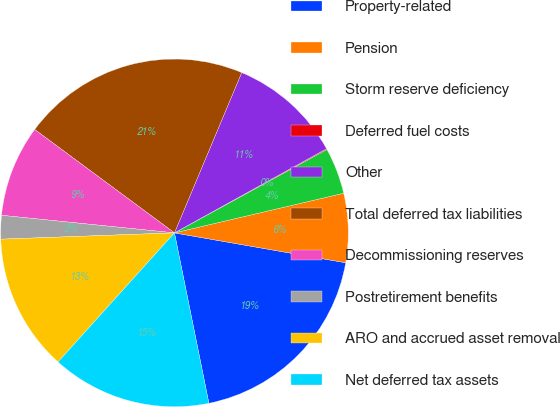Convert chart. <chart><loc_0><loc_0><loc_500><loc_500><pie_chart><fcel>Property-related<fcel>Pension<fcel>Storm reserve deficiency<fcel>Deferred fuel costs<fcel>Other<fcel>Total deferred tax liabilities<fcel>Decommissioning reserves<fcel>Postretirement benefits<fcel>ARO and accrued asset removal<fcel>Net deferred tax assets<nl><fcel>19.07%<fcel>6.41%<fcel>4.3%<fcel>0.08%<fcel>10.63%<fcel>21.18%<fcel>8.52%<fcel>2.19%<fcel>12.74%<fcel>14.85%<nl></chart> 